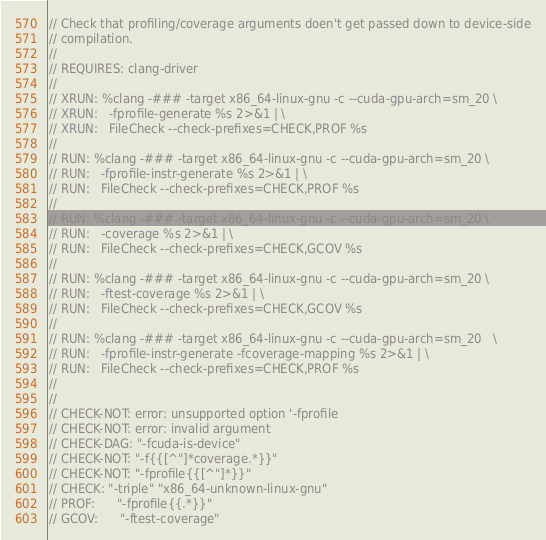<code> <loc_0><loc_0><loc_500><loc_500><_Cuda_>// Check that profiling/coverage arguments doen't get passed down to device-side
// compilation.
//
// REQUIRES: clang-driver
//
// XRUN: %clang -### -target x86_64-linux-gnu -c --cuda-gpu-arch=sm_20 \
// XRUN:   -fprofile-generate %s 2>&1 | \
// XRUN:   FileCheck --check-prefixes=CHECK,PROF %s
//
// RUN: %clang -### -target x86_64-linux-gnu -c --cuda-gpu-arch=sm_20 \
// RUN:   -fprofile-instr-generate %s 2>&1 | \
// RUN:   FileCheck --check-prefixes=CHECK,PROF %s
//
// RUN: %clang -### -target x86_64-linux-gnu -c --cuda-gpu-arch=sm_20 \
// RUN:   -coverage %s 2>&1 | \
// RUN:   FileCheck --check-prefixes=CHECK,GCOV %s
//
// RUN: %clang -### -target x86_64-linux-gnu -c --cuda-gpu-arch=sm_20 \
// RUN:   -ftest-coverage %s 2>&1 | \
// RUN:   FileCheck --check-prefixes=CHECK,GCOV %s
//
// RUN: %clang -### -target x86_64-linux-gnu -c --cuda-gpu-arch=sm_20   \
// RUN:   -fprofile-instr-generate -fcoverage-mapping %s 2>&1 | \
// RUN:   FileCheck --check-prefixes=CHECK,PROF %s
//
//
// CHECK-NOT: error: unsupported option '-fprofile
// CHECK-NOT: error: invalid argument
// CHECK-DAG: "-fcuda-is-device"
// CHECK-NOT: "-f{{[^"]*coverage.*}}"
// CHECK-NOT: "-fprofile{{[^"]*}}"
// CHECK: "-triple" "x86_64-unknown-linux-gnu"
// PROF:      "-fprofile{{.*}}"
// GCOV:      "-ftest-coverage"
</code> 